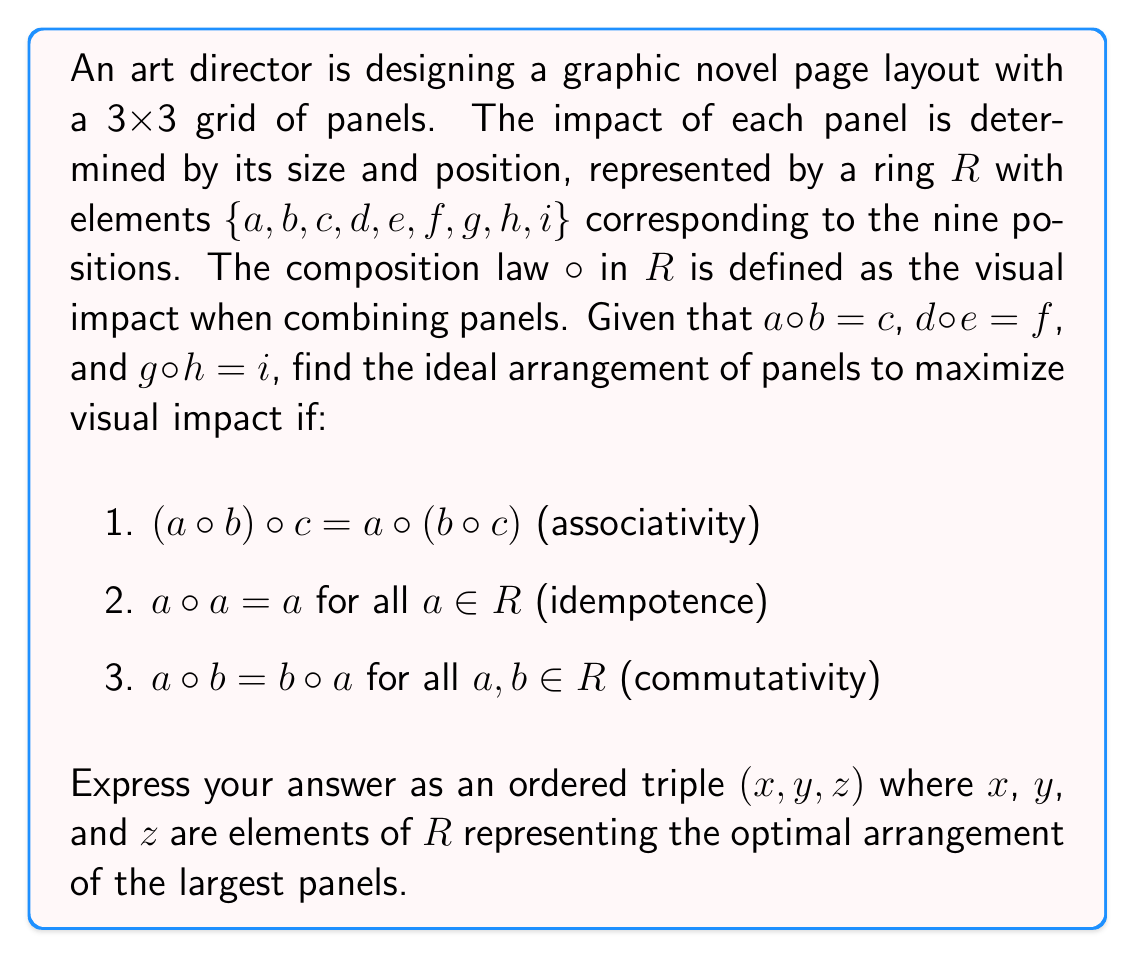Can you answer this question? To solve this problem, we need to analyze the properties of the ring $R$ and understand how they relate to the visual impact of panel arrangements.

1. Given the associativity property, we know that the order of combining panels doesn't matter for groups of three. This suggests that we can focus on maximizing the impact of individual combinations.

2. The idempotence property implies that combining a panel with itself doesn't increase its impact. This means we should use distinct panels for maximum effect.

3. Commutativity tells us that the order of combining two panels doesn't matter, which simplifies our analysis.

Now, let's consider the given information:
$a \circ b = c$
$d \circ e = f$
$g \circ h = i$

These equations show that combining certain pairs of panels results in a third panel. To maximize visual impact, we want to use the panels that result from these combinations, as they represent the highest impact.

The optimal arrangement would be to use the panels $c$, $f$, and $i$, as they are the result of combining other panels. This arrangement ensures that we're using the highest impact panels available.

The order of these panels in the layout doesn't matter due to the commutativity property, so any arrangement of $c$, $f$, and $i$ will yield the maximum visual impact.
Answer: $(c, f, i)$ 